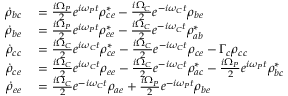Convert formula to latex. <formula><loc_0><loc_0><loc_500><loc_500>\begin{array} { r l } { \dot { \rho } _ { b c } } & = \frac { i \Omega _ { P } } { 2 } e ^ { i \omega _ { P } t } \rho _ { c e } ^ { * } - \frac { i \Omega _ { C } } { 2 } e ^ { - i \omega _ { C } t } \rho _ { b e } } \\ { \dot { \rho } _ { b e } } & = \frac { i \Omega _ { P } } { 2 } e ^ { i \omega _ { P } t } \rho _ { e e } ^ { * } - \frac { i \Omega _ { C } } { 2 } e ^ { - i \omega _ { C } t } \rho _ { a b } ^ { * } } \\ { \dot { \rho } _ { c c } } & = \frac { i \Omega _ { C } } { 2 } e ^ { i \omega _ { C } t } \rho _ { c e } ^ { * } - \frac { i \Omega _ { C } } { 2 } e ^ { - i \omega _ { C } t } \rho _ { c e } - \Gamma _ { c } \rho _ { c c } } \\ { \dot { \rho } _ { c e } } & = \frac { i \Omega _ { C } } { 2 } e ^ { i \omega _ { C } t } \rho _ { e e } - \frac { i \Omega _ { C } } { 2 } e ^ { - i \omega _ { C } t } \rho _ { a c } ^ { * } - \frac { i \Omega _ { P } } { 2 } e ^ { i \omega _ { P } t } \rho _ { b c } ^ { * } } \\ { \dot { \rho } _ { e e } } & = \frac { i \Omega _ { C } } { 2 } e ^ { - i \omega _ { C } t } \rho _ { a e } + \frac { i \Omega _ { P } } { 2 } e ^ { - i \omega _ { P } t } \rho _ { b e } } \end{array}</formula> 